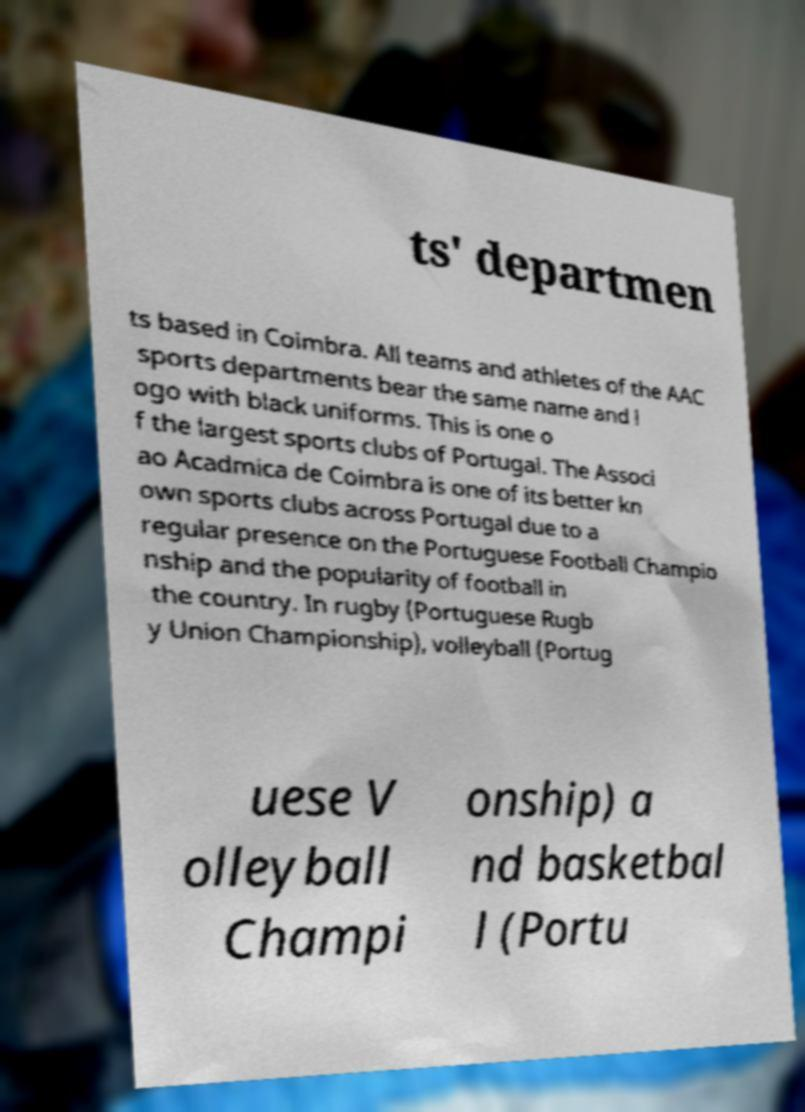What messages or text are displayed in this image? I need them in a readable, typed format. ts' departmen ts based in Coimbra. All teams and athletes of the AAC sports departments bear the same name and l ogo with black uniforms. This is one o f the largest sports clubs of Portugal. The Associ ao Acadmica de Coimbra is one of its better kn own sports clubs across Portugal due to a regular presence on the Portuguese Football Champio nship and the popularity of football in the country. In rugby (Portuguese Rugb y Union Championship), volleyball (Portug uese V olleyball Champi onship) a nd basketbal l (Portu 